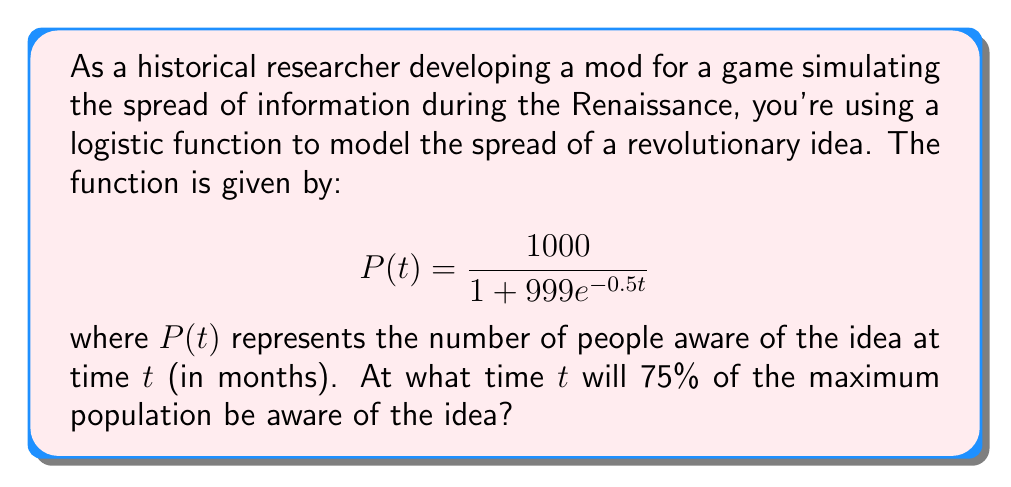Help me with this question. To solve this problem, we'll follow these steps:

1) First, we need to identify the maximum population. In a logistic function, this is the value that $P(t)$ approaches as $t$ approaches infinity. In this case, it's 1000.

2) We want to find when 75% of the maximum population is aware. That's:
   $0.75 \times 1000 = 750$ people

3) Now, we set up the equation:

   $$750 = \frac{1000}{1 + 999e^{-0.5t}}$$

4) Multiply both sides by $(1 + 999e^{-0.5t})$:

   $$750(1 + 999e^{-0.5t}) = 1000$$

5) Distribute on the left side:

   $$750 + 749250e^{-0.5t} = 1000$$

6) Subtract 750 from both sides:

   $$749250e^{-0.5t} = 250$$

7) Divide both sides by 749250:

   $$e^{-0.5t} = \frac{1}{2997}$$

8) Take the natural log of both sides:

   $$-0.5t = \ln(\frac{1}{2997})$$

9) Multiply both sides by -2:

   $$t = -2\ln(\frac{1}{2997}) = 2\ln(2997)$$

10) Calculate the final value:

    $$t \approx 16.21$$

Therefore, it will take approximately 16.21 months for 75% of the maximum population to be aware of the idea.
Answer: $t \approx 16.21$ months 